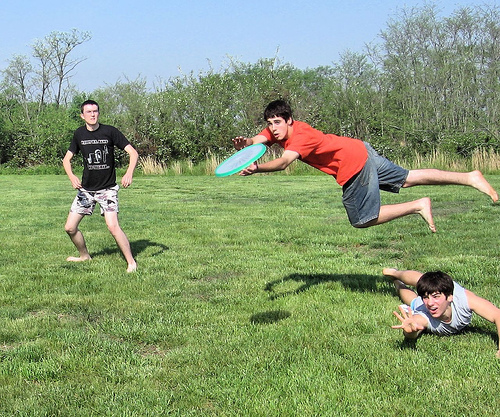Please provide the bounding box coordinate of the region this sentence describes: A person is laying in the grass. The coordinates for the region where a person is laying in the grass are: [0.73, 0.6, 0.99, 0.84]. 